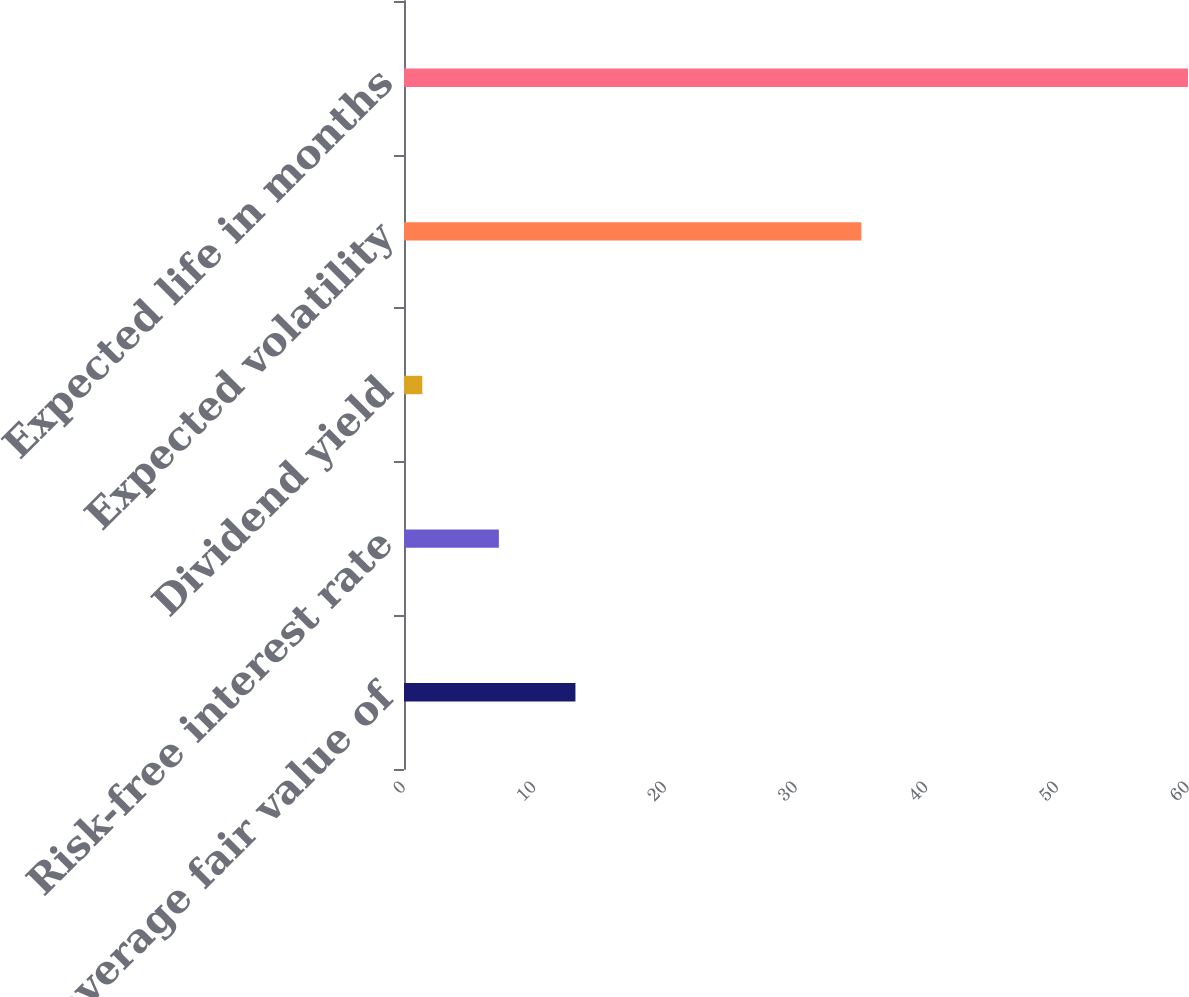<chart> <loc_0><loc_0><loc_500><loc_500><bar_chart><fcel>Weighted average fair value of<fcel>Risk-free interest rate<fcel>Dividend yield<fcel>Expected volatility<fcel>Expected life in months<nl><fcel>13.12<fcel>7.26<fcel>1.4<fcel>35<fcel>60<nl></chart> 